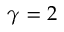<formula> <loc_0><loc_0><loc_500><loc_500>\gamma = 2</formula> 